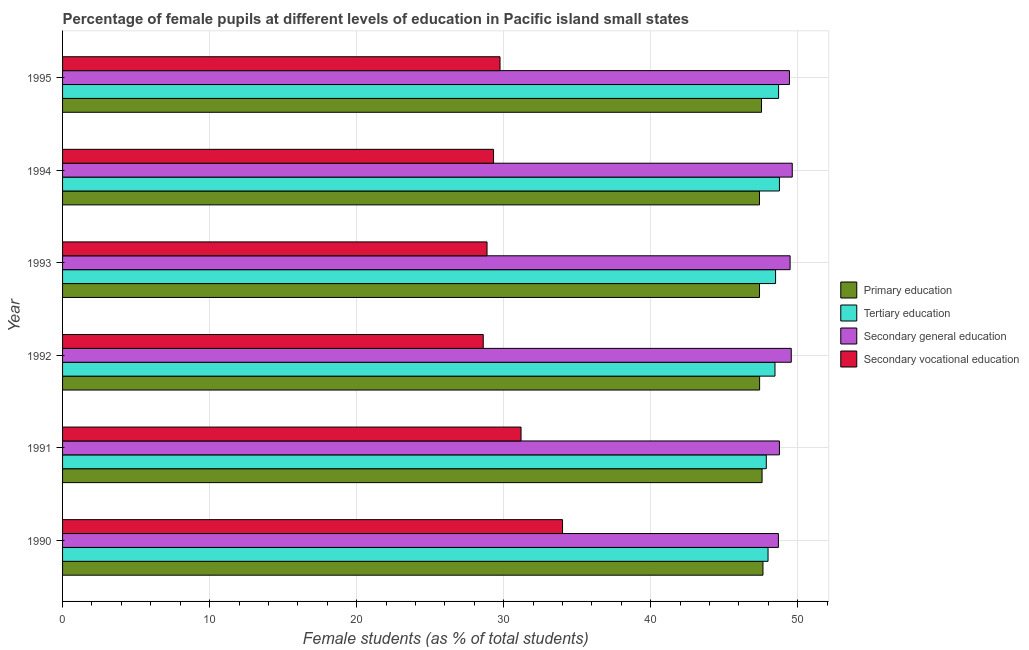How many different coloured bars are there?
Provide a short and direct response. 4. How many groups of bars are there?
Your answer should be compact. 6. Are the number of bars on each tick of the Y-axis equal?
Provide a succinct answer. Yes. How many bars are there on the 1st tick from the bottom?
Give a very brief answer. 4. What is the label of the 5th group of bars from the top?
Give a very brief answer. 1991. What is the percentage of female students in tertiary education in 1995?
Keep it short and to the point. 48.7. Across all years, what is the maximum percentage of female students in tertiary education?
Provide a short and direct response. 48.75. Across all years, what is the minimum percentage of female students in primary education?
Provide a short and direct response. 47.4. What is the total percentage of female students in primary education in the graph?
Provide a short and direct response. 284.94. What is the difference between the percentage of female students in secondary vocational education in 1990 and that in 1993?
Keep it short and to the point. 5.13. What is the difference between the percentage of female students in primary education in 1994 and the percentage of female students in secondary vocational education in 1992?
Your answer should be very brief. 18.79. What is the average percentage of female students in tertiary education per year?
Offer a terse response. 48.37. In the year 1993, what is the difference between the percentage of female students in secondary education and percentage of female students in tertiary education?
Give a very brief answer. 0.99. What is the ratio of the percentage of female students in primary education in 1990 to that in 1992?
Offer a terse response. 1. Is the percentage of female students in primary education in 1991 less than that in 1994?
Provide a succinct answer. No. Is the difference between the percentage of female students in tertiary education in 1990 and 1993 greater than the difference between the percentage of female students in secondary education in 1990 and 1993?
Make the answer very short. Yes. What is the difference between the highest and the second highest percentage of female students in secondary vocational education?
Provide a short and direct response. 2.82. What is the difference between the highest and the lowest percentage of female students in tertiary education?
Provide a short and direct response. 0.89. Is the sum of the percentage of female students in primary education in 1993 and 1994 greater than the maximum percentage of female students in secondary vocational education across all years?
Offer a very short reply. Yes. What does the 3rd bar from the top in 1990 represents?
Your response must be concise. Tertiary education. What does the 4th bar from the bottom in 1992 represents?
Offer a terse response. Secondary vocational education. How many bars are there?
Ensure brevity in your answer.  24. What is the difference between two consecutive major ticks on the X-axis?
Offer a terse response. 10. Are the values on the major ticks of X-axis written in scientific E-notation?
Your answer should be very brief. No. How are the legend labels stacked?
Make the answer very short. Vertical. What is the title of the graph?
Ensure brevity in your answer.  Percentage of female pupils at different levels of education in Pacific island small states. What is the label or title of the X-axis?
Make the answer very short. Female students (as % of total students). What is the Female students (as % of total students) of Primary education in 1990?
Give a very brief answer. 47.63. What is the Female students (as % of total students) in Tertiary education in 1990?
Give a very brief answer. 47.98. What is the Female students (as % of total students) of Secondary general education in 1990?
Offer a very short reply. 48.68. What is the Female students (as % of total students) in Secondary vocational education in 1990?
Provide a succinct answer. 34. What is the Female students (as % of total students) in Primary education in 1991?
Offer a terse response. 47.57. What is the Female students (as % of total students) of Tertiary education in 1991?
Your response must be concise. 47.86. What is the Female students (as % of total students) of Secondary general education in 1991?
Give a very brief answer. 48.75. What is the Female students (as % of total students) in Secondary vocational education in 1991?
Your answer should be compact. 31.18. What is the Female students (as % of total students) in Primary education in 1992?
Make the answer very short. 47.4. What is the Female students (as % of total students) of Tertiary education in 1992?
Your answer should be compact. 48.45. What is the Female students (as % of total students) of Secondary general education in 1992?
Keep it short and to the point. 49.56. What is the Female students (as % of total students) of Secondary vocational education in 1992?
Ensure brevity in your answer.  28.61. What is the Female students (as % of total students) of Primary education in 1993?
Your answer should be compact. 47.4. What is the Female students (as % of total students) in Tertiary education in 1993?
Your response must be concise. 48.49. What is the Female students (as % of total students) of Secondary general education in 1993?
Keep it short and to the point. 49.48. What is the Female students (as % of total students) in Secondary vocational education in 1993?
Ensure brevity in your answer.  28.87. What is the Female students (as % of total students) of Primary education in 1994?
Provide a succinct answer. 47.4. What is the Female students (as % of total students) of Tertiary education in 1994?
Your answer should be compact. 48.75. What is the Female students (as % of total students) in Secondary general education in 1994?
Keep it short and to the point. 49.63. What is the Female students (as % of total students) in Secondary vocational education in 1994?
Provide a short and direct response. 29.31. What is the Female students (as % of total students) of Primary education in 1995?
Ensure brevity in your answer.  47.53. What is the Female students (as % of total students) of Tertiary education in 1995?
Ensure brevity in your answer.  48.7. What is the Female students (as % of total students) of Secondary general education in 1995?
Provide a succinct answer. 49.43. What is the Female students (as % of total students) in Secondary vocational education in 1995?
Make the answer very short. 29.75. Across all years, what is the maximum Female students (as % of total students) of Primary education?
Your answer should be very brief. 47.63. Across all years, what is the maximum Female students (as % of total students) in Tertiary education?
Give a very brief answer. 48.75. Across all years, what is the maximum Female students (as % of total students) in Secondary general education?
Your answer should be very brief. 49.63. Across all years, what is the maximum Female students (as % of total students) in Secondary vocational education?
Your response must be concise. 34. Across all years, what is the minimum Female students (as % of total students) of Primary education?
Offer a very short reply. 47.4. Across all years, what is the minimum Female students (as % of total students) of Tertiary education?
Ensure brevity in your answer.  47.86. Across all years, what is the minimum Female students (as % of total students) in Secondary general education?
Your answer should be very brief. 48.68. Across all years, what is the minimum Female students (as % of total students) of Secondary vocational education?
Offer a very short reply. 28.61. What is the total Female students (as % of total students) of Primary education in the graph?
Your response must be concise. 284.94. What is the total Female students (as % of total students) in Tertiary education in the graph?
Your answer should be very brief. 290.22. What is the total Female students (as % of total students) in Secondary general education in the graph?
Provide a short and direct response. 295.53. What is the total Female students (as % of total students) in Secondary vocational education in the graph?
Give a very brief answer. 181.72. What is the difference between the Female students (as % of total students) in Primary education in 1990 and that in 1991?
Provide a succinct answer. 0.06. What is the difference between the Female students (as % of total students) of Tertiary education in 1990 and that in 1991?
Offer a very short reply. 0.12. What is the difference between the Female students (as % of total students) of Secondary general education in 1990 and that in 1991?
Keep it short and to the point. -0.07. What is the difference between the Female students (as % of total students) in Secondary vocational education in 1990 and that in 1991?
Your answer should be compact. 2.82. What is the difference between the Female students (as % of total students) in Primary education in 1990 and that in 1992?
Your answer should be very brief. 0.23. What is the difference between the Female students (as % of total students) of Tertiary education in 1990 and that in 1992?
Provide a succinct answer. -0.47. What is the difference between the Female students (as % of total students) in Secondary general education in 1990 and that in 1992?
Give a very brief answer. -0.87. What is the difference between the Female students (as % of total students) of Secondary vocational education in 1990 and that in 1992?
Give a very brief answer. 5.39. What is the difference between the Female students (as % of total students) of Primary education in 1990 and that in 1993?
Your answer should be compact. 0.23. What is the difference between the Female students (as % of total students) in Tertiary education in 1990 and that in 1993?
Ensure brevity in your answer.  -0.51. What is the difference between the Female students (as % of total students) of Secondary general education in 1990 and that in 1993?
Offer a terse response. -0.8. What is the difference between the Female students (as % of total students) of Secondary vocational education in 1990 and that in 1993?
Your response must be concise. 5.13. What is the difference between the Female students (as % of total students) in Primary education in 1990 and that in 1994?
Provide a short and direct response. 0.24. What is the difference between the Female students (as % of total students) of Tertiary education in 1990 and that in 1994?
Ensure brevity in your answer.  -0.77. What is the difference between the Female students (as % of total students) of Secondary general education in 1990 and that in 1994?
Provide a succinct answer. -0.94. What is the difference between the Female students (as % of total students) in Secondary vocational education in 1990 and that in 1994?
Keep it short and to the point. 4.69. What is the difference between the Female students (as % of total students) of Primary education in 1990 and that in 1995?
Give a very brief answer. 0.1. What is the difference between the Female students (as % of total students) in Tertiary education in 1990 and that in 1995?
Provide a succinct answer. -0.72. What is the difference between the Female students (as % of total students) in Secondary general education in 1990 and that in 1995?
Offer a very short reply. -0.75. What is the difference between the Female students (as % of total students) in Secondary vocational education in 1990 and that in 1995?
Give a very brief answer. 4.25. What is the difference between the Female students (as % of total students) in Primary education in 1991 and that in 1992?
Provide a short and direct response. 0.17. What is the difference between the Female students (as % of total students) in Tertiary education in 1991 and that in 1992?
Your response must be concise. -0.59. What is the difference between the Female students (as % of total students) in Secondary general education in 1991 and that in 1992?
Offer a very short reply. -0.8. What is the difference between the Female students (as % of total students) of Secondary vocational education in 1991 and that in 1992?
Make the answer very short. 2.57. What is the difference between the Female students (as % of total students) of Primary education in 1991 and that in 1993?
Offer a very short reply. 0.17. What is the difference between the Female students (as % of total students) of Tertiary education in 1991 and that in 1993?
Offer a terse response. -0.63. What is the difference between the Female students (as % of total students) of Secondary general education in 1991 and that in 1993?
Make the answer very short. -0.73. What is the difference between the Female students (as % of total students) of Secondary vocational education in 1991 and that in 1993?
Your answer should be very brief. 2.31. What is the difference between the Female students (as % of total students) of Primary education in 1991 and that in 1994?
Your answer should be compact. 0.18. What is the difference between the Female students (as % of total students) of Tertiary education in 1991 and that in 1994?
Keep it short and to the point. -0.89. What is the difference between the Female students (as % of total students) of Secondary general education in 1991 and that in 1994?
Make the answer very short. -0.87. What is the difference between the Female students (as % of total students) in Secondary vocational education in 1991 and that in 1994?
Offer a terse response. 1.87. What is the difference between the Female students (as % of total students) in Primary education in 1991 and that in 1995?
Provide a short and direct response. 0.04. What is the difference between the Female students (as % of total students) in Tertiary education in 1991 and that in 1995?
Offer a very short reply. -0.84. What is the difference between the Female students (as % of total students) of Secondary general education in 1991 and that in 1995?
Your answer should be very brief. -0.68. What is the difference between the Female students (as % of total students) in Secondary vocational education in 1991 and that in 1995?
Keep it short and to the point. 1.43. What is the difference between the Female students (as % of total students) in Primary education in 1992 and that in 1993?
Ensure brevity in your answer.  0.01. What is the difference between the Female students (as % of total students) of Tertiary education in 1992 and that in 1993?
Offer a very short reply. -0.04. What is the difference between the Female students (as % of total students) in Secondary general education in 1992 and that in 1993?
Your answer should be compact. 0.08. What is the difference between the Female students (as % of total students) of Secondary vocational education in 1992 and that in 1993?
Offer a very short reply. -0.26. What is the difference between the Female students (as % of total students) in Primary education in 1992 and that in 1994?
Make the answer very short. 0.01. What is the difference between the Female students (as % of total students) in Tertiary education in 1992 and that in 1994?
Offer a very short reply. -0.3. What is the difference between the Female students (as % of total students) of Secondary general education in 1992 and that in 1994?
Your answer should be compact. -0.07. What is the difference between the Female students (as % of total students) of Secondary vocational education in 1992 and that in 1994?
Ensure brevity in your answer.  -0.7. What is the difference between the Female students (as % of total students) in Primary education in 1992 and that in 1995?
Ensure brevity in your answer.  -0.13. What is the difference between the Female students (as % of total students) in Tertiary education in 1992 and that in 1995?
Your answer should be very brief. -0.25. What is the difference between the Female students (as % of total students) of Secondary general education in 1992 and that in 1995?
Offer a very short reply. 0.12. What is the difference between the Female students (as % of total students) in Secondary vocational education in 1992 and that in 1995?
Provide a succinct answer. -1.14. What is the difference between the Female students (as % of total students) in Primary education in 1993 and that in 1994?
Make the answer very short. 0. What is the difference between the Female students (as % of total students) of Tertiary education in 1993 and that in 1994?
Keep it short and to the point. -0.26. What is the difference between the Female students (as % of total students) of Secondary general education in 1993 and that in 1994?
Make the answer very short. -0.15. What is the difference between the Female students (as % of total students) in Secondary vocational education in 1993 and that in 1994?
Provide a short and direct response. -0.44. What is the difference between the Female students (as % of total students) in Primary education in 1993 and that in 1995?
Offer a terse response. -0.14. What is the difference between the Female students (as % of total students) of Tertiary education in 1993 and that in 1995?
Make the answer very short. -0.21. What is the difference between the Female students (as % of total students) in Secondary general education in 1993 and that in 1995?
Give a very brief answer. 0.04. What is the difference between the Female students (as % of total students) in Secondary vocational education in 1993 and that in 1995?
Offer a very short reply. -0.88. What is the difference between the Female students (as % of total students) of Primary education in 1994 and that in 1995?
Your answer should be compact. -0.14. What is the difference between the Female students (as % of total students) of Tertiary education in 1994 and that in 1995?
Provide a short and direct response. 0.06. What is the difference between the Female students (as % of total students) in Secondary general education in 1994 and that in 1995?
Provide a succinct answer. 0.19. What is the difference between the Female students (as % of total students) in Secondary vocational education in 1994 and that in 1995?
Offer a very short reply. -0.44. What is the difference between the Female students (as % of total students) of Primary education in 1990 and the Female students (as % of total students) of Tertiary education in 1991?
Your response must be concise. -0.23. What is the difference between the Female students (as % of total students) in Primary education in 1990 and the Female students (as % of total students) in Secondary general education in 1991?
Offer a very short reply. -1.12. What is the difference between the Female students (as % of total students) of Primary education in 1990 and the Female students (as % of total students) of Secondary vocational education in 1991?
Offer a terse response. 16.45. What is the difference between the Female students (as % of total students) in Tertiary education in 1990 and the Female students (as % of total students) in Secondary general education in 1991?
Ensure brevity in your answer.  -0.77. What is the difference between the Female students (as % of total students) in Tertiary education in 1990 and the Female students (as % of total students) in Secondary vocational education in 1991?
Your answer should be compact. 16.8. What is the difference between the Female students (as % of total students) in Secondary general education in 1990 and the Female students (as % of total students) in Secondary vocational education in 1991?
Your answer should be very brief. 17.5. What is the difference between the Female students (as % of total students) in Primary education in 1990 and the Female students (as % of total students) in Tertiary education in 1992?
Make the answer very short. -0.82. What is the difference between the Female students (as % of total students) in Primary education in 1990 and the Female students (as % of total students) in Secondary general education in 1992?
Offer a very short reply. -1.92. What is the difference between the Female students (as % of total students) in Primary education in 1990 and the Female students (as % of total students) in Secondary vocational education in 1992?
Offer a very short reply. 19.02. What is the difference between the Female students (as % of total students) of Tertiary education in 1990 and the Female students (as % of total students) of Secondary general education in 1992?
Provide a succinct answer. -1.58. What is the difference between the Female students (as % of total students) in Tertiary education in 1990 and the Female students (as % of total students) in Secondary vocational education in 1992?
Offer a terse response. 19.37. What is the difference between the Female students (as % of total students) of Secondary general education in 1990 and the Female students (as % of total students) of Secondary vocational education in 1992?
Make the answer very short. 20.07. What is the difference between the Female students (as % of total students) of Primary education in 1990 and the Female students (as % of total students) of Tertiary education in 1993?
Give a very brief answer. -0.86. What is the difference between the Female students (as % of total students) of Primary education in 1990 and the Female students (as % of total students) of Secondary general education in 1993?
Offer a terse response. -1.85. What is the difference between the Female students (as % of total students) of Primary education in 1990 and the Female students (as % of total students) of Secondary vocational education in 1993?
Offer a very short reply. 18.77. What is the difference between the Female students (as % of total students) of Tertiary education in 1990 and the Female students (as % of total students) of Secondary general education in 1993?
Keep it short and to the point. -1.5. What is the difference between the Female students (as % of total students) of Tertiary education in 1990 and the Female students (as % of total students) of Secondary vocational education in 1993?
Provide a short and direct response. 19.11. What is the difference between the Female students (as % of total students) of Secondary general education in 1990 and the Female students (as % of total students) of Secondary vocational education in 1993?
Offer a very short reply. 19.82. What is the difference between the Female students (as % of total students) in Primary education in 1990 and the Female students (as % of total students) in Tertiary education in 1994?
Ensure brevity in your answer.  -1.12. What is the difference between the Female students (as % of total students) of Primary education in 1990 and the Female students (as % of total students) of Secondary general education in 1994?
Make the answer very short. -1.99. What is the difference between the Female students (as % of total students) of Primary education in 1990 and the Female students (as % of total students) of Secondary vocational education in 1994?
Your response must be concise. 18.32. What is the difference between the Female students (as % of total students) in Tertiary education in 1990 and the Female students (as % of total students) in Secondary general education in 1994?
Keep it short and to the point. -1.65. What is the difference between the Female students (as % of total students) in Tertiary education in 1990 and the Female students (as % of total students) in Secondary vocational education in 1994?
Offer a very short reply. 18.67. What is the difference between the Female students (as % of total students) of Secondary general education in 1990 and the Female students (as % of total students) of Secondary vocational education in 1994?
Provide a succinct answer. 19.37. What is the difference between the Female students (as % of total students) of Primary education in 1990 and the Female students (as % of total students) of Tertiary education in 1995?
Ensure brevity in your answer.  -1.06. What is the difference between the Female students (as % of total students) in Primary education in 1990 and the Female students (as % of total students) in Secondary general education in 1995?
Your answer should be very brief. -1.8. What is the difference between the Female students (as % of total students) in Primary education in 1990 and the Female students (as % of total students) in Secondary vocational education in 1995?
Your response must be concise. 17.88. What is the difference between the Female students (as % of total students) of Tertiary education in 1990 and the Female students (as % of total students) of Secondary general education in 1995?
Offer a terse response. -1.46. What is the difference between the Female students (as % of total students) of Tertiary education in 1990 and the Female students (as % of total students) of Secondary vocational education in 1995?
Your answer should be very brief. 18.23. What is the difference between the Female students (as % of total students) of Secondary general education in 1990 and the Female students (as % of total students) of Secondary vocational education in 1995?
Make the answer very short. 18.93. What is the difference between the Female students (as % of total students) of Primary education in 1991 and the Female students (as % of total students) of Tertiary education in 1992?
Provide a succinct answer. -0.88. What is the difference between the Female students (as % of total students) of Primary education in 1991 and the Female students (as % of total students) of Secondary general education in 1992?
Provide a short and direct response. -1.98. What is the difference between the Female students (as % of total students) of Primary education in 1991 and the Female students (as % of total students) of Secondary vocational education in 1992?
Your answer should be very brief. 18.96. What is the difference between the Female students (as % of total students) in Tertiary education in 1991 and the Female students (as % of total students) in Secondary general education in 1992?
Provide a short and direct response. -1.7. What is the difference between the Female students (as % of total students) in Tertiary education in 1991 and the Female students (as % of total students) in Secondary vocational education in 1992?
Ensure brevity in your answer.  19.25. What is the difference between the Female students (as % of total students) in Secondary general education in 1991 and the Female students (as % of total students) in Secondary vocational education in 1992?
Offer a very short reply. 20.14. What is the difference between the Female students (as % of total students) of Primary education in 1991 and the Female students (as % of total students) of Tertiary education in 1993?
Your answer should be very brief. -0.92. What is the difference between the Female students (as % of total students) of Primary education in 1991 and the Female students (as % of total students) of Secondary general education in 1993?
Your answer should be very brief. -1.91. What is the difference between the Female students (as % of total students) of Primary education in 1991 and the Female students (as % of total students) of Secondary vocational education in 1993?
Offer a terse response. 18.71. What is the difference between the Female students (as % of total students) of Tertiary education in 1991 and the Female students (as % of total students) of Secondary general education in 1993?
Keep it short and to the point. -1.62. What is the difference between the Female students (as % of total students) of Tertiary education in 1991 and the Female students (as % of total students) of Secondary vocational education in 1993?
Provide a succinct answer. 18.99. What is the difference between the Female students (as % of total students) in Secondary general education in 1991 and the Female students (as % of total students) in Secondary vocational education in 1993?
Provide a short and direct response. 19.89. What is the difference between the Female students (as % of total students) in Primary education in 1991 and the Female students (as % of total students) in Tertiary education in 1994?
Provide a succinct answer. -1.18. What is the difference between the Female students (as % of total students) of Primary education in 1991 and the Female students (as % of total students) of Secondary general education in 1994?
Your response must be concise. -2.05. What is the difference between the Female students (as % of total students) of Primary education in 1991 and the Female students (as % of total students) of Secondary vocational education in 1994?
Ensure brevity in your answer.  18.26. What is the difference between the Female students (as % of total students) in Tertiary education in 1991 and the Female students (as % of total students) in Secondary general education in 1994?
Your answer should be very brief. -1.77. What is the difference between the Female students (as % of total students) of Tertiary education in 1991 and the Female students (as % of total students) of Secondary vocational education in 1994?
Make the answer very short. 18.55. What is the difference between the Female students (as % of total students) of Secondary general education in 1991 and the Female students (as % of total students) of Secondary vocational education in 1994?
Your answer should be compact. 19.44. What is the difference between the Female students (as % of total students) of Primary education in 1991 and the Female students (as % of total students) of Tertiary education in 1995?
Your answer should be compact. -1.12. What is the difference between the Female students (as % of total students) in Primary education in 1991 and the Female students (as % of total students) in Secondary general education in 1995?
Ensure brevity in your answer.  -1.86. What is the difference between the Female students (as % of total students) of Primary education in 1991 and the Female students (as % of total students) of Secondary vocational education in 1995?
Your answer should be compact. 17.82. What is the difference between the Female students (as % of total students) of Tertiary education in 1991 and the Female students (as % of total students) of Secondary general education in 1995?
Your answer should be compact. -1.57. What is the difference between the Female students (as % of total students) in Tertiary education in 1991 and the Female students (as % of total students) in Secondary vocational education in 1995?
Your answer should be compact. 18.11. What is the difference between the Female students (as % of total students) in Secondary general education in 1991 and the Female students (as % of total students) in Secondary vocational education in 1995?
Your response must be concise. 19. What is the difference between the Female students (as % of total students) of Primary education in 1992 and the Female students (as % of total students) of Tertiary education in 1993?
Your response must be concise. -1.09. What is the difference between the Female students (as % of total students) in Primary education in 1992 and the Female students (as % of total students) in Secondary general education in 1993?
Keep it short and to the point. -2.07. What is the difference between the Female students (as % of total students) in Primary education in 1992 and the Female students (as % of total students) in Secondary vocational education in 1993?
Ensure brevity in your answer.  18.54. What is the difference between the Female students (as % of total students) of Tertiary education in 1992 and the Female students (as % of total students) of Secondary general education in 1993?
Keep it short and to the point. -1.03. What is the difference between the Female students (as % of total students) in Tertiary education in 1992 and the Female students (as % of total students) in Secondary vocational education in 1993?
Keep it short and to the point. 19.58. What is the difference between the Female students (as % of total students) in Secondary general education in 1992 and the Female students (as % of total students) in Secondary vocational education in 1993?
Make the answer very short. 20.69. What is the difference between the Female students (as % of total students) in Primary education in 1992 and the Female students (as % of total students) in Tertiary education in 1994?
Keep it short and to the point. -1.35. What is the difference between the Female students (as % of total students) of Primary education in 1992 and the Female students (as % of total students) of Secondary general education in 1994?
Provide a short and direct response. -2.22. What is the difference between the Female students (as % of total students) of Primary education in 1992 and the Female students (as % of total students) of Secondary vocational education in 1994?
Give a very brief answer. 18.09. What is the difference between the Female students (as % of total students) of Tertiary education in 1992 and the Female students (as % of total students) of Secondary general education in 1994?
Provide a succinct answer. -1.18. What is the difference between the Female students (as % of total students) in Tertiary education in 1992 and the Female students (as % of total students) in Secondary vocational education in 1994?
Provide a short and direct response. 19.14. What is the difference between the Female students (as % of total students) in Secondary general education in 1992 and the Female students (as % of total students) in Secondary vocational education in 1994?
Your response must be concise. 20.25. What is the difference between the Female students (as % of total students) in Primary education in 1992 and the Female students (as % of total students) in Tertiary education in 1995?
Your answer should be very brief. -1.29. What is the difference between the Female students (as % of total students) of Primary education in 1992 and the Female students (as % of total students) of Secondary general education in 1995?
Ensure brevity in your answer.  -2.03. What is the difference between the Female students (as % of total students) of Primary education in 1992 and the Female students (as % of total students) of Secondary vocational education in 1995?
Your answer should be very brief. 17.65. What is the difference between the Female students (as % of total students) of Tertiary education in 1992 and the Female students (as % of total students) of Secondary general education in 1995?
Give a very brief answer. -0.98. What is the difference between the Female students (as % of total students) of Tertiary education in 1992 and the Female students (as % of total students) of Secondary vocational education in 1995?
Keep it short and to the point. 18.7. What is the difference between the Female students (as % of total students) of Secondary general education in 1992 and the Female students (as % of total students) of Secondary vocational education in 1995?
Provide a short and direct response. 19.81. What is the difference between the Female students (as % of total students) in Primary education in 1993 and the Female students (as % of total students) in Tertiary education in 1994?
Keep it short and to the point. -1.35. What is the difference between the Female students (as % of total students) in Primary education in 1993 and the Female students (as % of total students) in Secondary general education in 1994?
Make the answer very short. -2.23. What is the difference between the Female students (as % of total students) in Primary education in 1993 and the Female students (as % of total students) in Secondary vocational education in 1994?
Offer a terse response. 18.09. What is the difference between the Female students (as % of total students) in Tertiary education in 1993 and the Female students (as % of total students) in Secondary general education in 1994?
Make the answer very short. -1.14. What is the difference between the Female students (as % of total students) of Tertiary education in 1993 and the Female students (as % of total students) of Secondary vocational education in 1994?
Provide a succinct answer. 19.18. What is the difference between the Female students (as % of total students) of Secondary general education in 1993 and the Female students (as % of total students) of Secondary vocational education in 1994?
Your response must be concise. 20.17. What is the difference between the Female students (as % of total students) in Primary education in 1993 and the Female students (as % of total students) in Tertiary education in 1995?
Offer a very short reply. -1.3. What is the difference between the Female students (as % of total students) in Primary education in 1993 and the Female students (as % of total students) in Secondary general education in 1995?
Make the answer very short. -2.04. What is the difference between the Female students (as % of total students) of Primary education in 1993 and the Female students (as % of total students) of Secondary vocational education in 1995?
Your answer should be compact. 17.65. What is the difference between the Female students (as % of total students) of Tertiary education in 1993 and the Female students (as % of total students) of Secondary general education in 1995?
Keep it short and to the point. -0.94. What is the difference between the Female students (as % of total students) of Tertiary education in 1993 and the Female students (as % of total students) of Secondary vocational education in 1995?
Ensure brevity in your answer.  18.74. What is the difference between the Female students (as % of total students) in Secondary general education in 1993 and the Female students (as % of total students) in Secondary vocational education in 1995?
Make the answer very short. 19.73. What is the difference between the Female students (as % of total students) in Primary education in 1994 and the Female students (as % of total students) in Tertiary education in 1995?
Offer a terse response. -1.3. What is the difference between the Female students (as % of total students) in Primary education in 1994 and the Female students (as % of total students) in Secondary general education in 1995?
Provide a succinct answer. -2.04. What is the difference between the Female students (as % of total students) of Primary education in 1994 and the Female students (as % of total students) of Secondary vocational education in 1995?
Your answer should be very brief. 17.65. What is the difference between the Female students (as % of total students) of Tertiary education in 1994 and the Female students (as % of total students) of Secondary general education in 1995?
Your answer should be compact. -0.68. What is the difference between the Female students (as % of total students) of Tertiary education in 1994 and the Female students (as % of total students) of Secondary vocational education in 1995?
Provide a short and direct response. 19. What is the difference between the Female students (as % of total students) in Secondary general education in 1994 and the Female students (as % of total students) in Secondary vocational education in 1995?
Your response must be concise. 19.88. What is the average Female students (as % of total students) of Primary education per year?
Make the answer very short. 47.49. What is the average Female students (as % of total students) in Tertiary education per year?
Your answer should be very brief. 48.37. What is the average Female students (as % of total students) in Secondary general education per year?
Provide a succinct answer. 49.25. What is the average Female students (as % of total students) of Secondary vocational education per year?
Offer a very short reply. 30.29. In the year 1990, what is the difference between the Female students (as % of total students) of Primary education and Female students (as % of total students) of Tertiary education?
Offer a very short reply. -0.35. In the year 1990, what is the difference between the Female students (as % of total students) in Primary education and Female students (as % of total students) in Secondary general education?
Ensure brevity in your answer.  -1.05. In the year 1990, what is the difference between the Female students (as % of total students) in Primary education and Female students (as % of total students) in Secondary vocational education?
Provide a short and direct response. 13.63. In the year 1990, what is the difference between the Female students (as % of total students) in Tertiary education and Female students (as % of total students) in Secondary general education?
Offer a very short reply. -0.7. In the year 1990, what is the difference between the Female students (as % of total students) of Tertiary education and Female students (as % of total students) of Secondary vocational education?
Give a very brief answer. 13.98. In the year 1990, what is the difference between the Female students (as % of total students) of Secondary general education and Female students (as % of total students) of Secondary vocational education?
Offer a terse response. 14.68. In the year 1991, what is the difference between the Female students (as % of total students) in Primary education and Female students (as % of total students) in Tertiary education?
Offer a very short reply. -0.29. In the year 1991, what is the difference between the Female students (as % of total students) in Primary education and Female students (as % of total students) in Secondary general education?
Offer a terse response. -1.18. In the year 1991, what is the difference between the Female students (as % of total students) of Primary education and Female students (as % of total students) of Secondary vocational education?
Your answer should be compact. 16.39. In the year 1991, what is the difference between the Female students (as % of total students) in Tertiary education and Female students (as % of total students) in Secondary general education?
Offer a very short reply. -0.89. In the year 1991, what is the difference between the Female students (as % of total students) in Tertiary education and Female students (as % of total students) in Secondary vocational education?
Make the answer very short. 16.68. In the year 1991, what is the difference between the Female students (as % of total students) of Secondary general education and Female students (as % of total students) of Secondary vocational education?
Provide a short and direct response. 17.57. In the year 1992, what is the difference between the Female students (as % of total students) of Primary education and Female students (as % of total students) of Tertiary education?
Your answer should be compact. -1.05. In the year 1992, what is the difference between the Female students (as % of total students) of Primary education and Female students (as % of total students) of Secondary general education?
Keep it short and to the point. -2.15. In the year 1992, what is the difference between the Female students (as % of total students) of Primary education and Female students (as % of total students) of Secondary vocational education?
Your response must be concise. 18.8. In the year 1992, what is the difference between the Female students (as % of total students) in Tertiary education and Female students (as % of total students) in Secondary general education?
Your answer should be very brief. -1.11. In the year 1992, what is the difference between the Female students (as % of total students) of Tertiary education and Female students (as % of total students) of Secondary vocational education?
Offer a very short reply. 19.84. In the year 1992, what is the difference between the Female students (as % of total students) in Secondary general education and Female students (as % of total students) in Secondary vocational education?
Your response must be concise. 20.95. In the year 1993, what is the difference between the Female students (as % of total students) in Primary education and Female students (as % of total students) in Tertiary education?
Provide a succinct answer. -1.09. In the year 1993, what is the difference between the Female students (as % of total students) of Primary education and Female students (as % of total students) of Secondary general education?
Make the answer very short. -2.08. In the year 1993, what is the difference between the Female students (as % of total students) in Primary education and Female students (as % of total students) in Secondary vocational education?
Your response must be concise. 18.53. In the year 1993, what is the difference between the Female students (as % of total students) in Tertiary education and Female students (as % of total students) in Secondary general education?
Give a very brief answer. -0.99. In the year 1993, what is the difference between the Female students (as % of total students) in Tertiary education and Female students (as % of total students) in Secondary vocational education?
Your response must be concise. 19.62. In the year 1993, what is the difference between the Female students (as % of total students) of Secondary general education and Female students (as % of total students) of Secondary vocational education?
Your answer should be compact. 20.61. In the year 1994, what is the difference between the Female students (as % of total students) in Primary education and Female students (as % of total students) in Tertiary education?
Offer a terse response. -1.36. In the year 1994, what is the difference between the Female students (as % of total students) in Primary education and Female students (as % of total students) in Secondary general education?
Keep it short and to the point. -2.23. In the year 1994, what is the difference between the Female students (as % of total students) in Primary education and Female students (as % of total students) in Secondary vocational education?
Your answer should be very brief. 18.09. In the year 1994, what is the difference between the Female students (as % of total students) of Tertiary education and Female students (as % of total students) of Secondary general education?
Keep it short and to the point. -0.87. In the year 1994, what is the difference between the Female students (as % of total students) in Tertiary education and Female students (as % of total students) in Secondary vocational education?
Keep it short and to the point. 19.44. In the year 1994, what is the difference between the Female students (as % of total students) in Secondary general education and Female students (as % of total students) in Secondary vocational education?
Provide a short and direct response. 20.32. In the year 1995, what is the difference between the Female students (as % of total students) of Primary education and Female students (as % of total students) of Tertiary education?
Ensure brevity in your answer.  -1.16. In the year 1995, what is the difference between the Female students (as % of total students) of Primary education and Female students (as % of total students) of Secondary general education?
Your answer should be compact. -1.9. In the year 1995, what is the difference between the Female students (as % of total students) in Primary education and Female students (as % of total students) in Secondary vocational education?
Your response must be concise. 17.78. In the year 1995, what is the difference between the Female students (as % of total students) in Tertiary education and Female students (as % of total students) in Secondary general education?
Provide a succinct answer. -0.74. In the year 1995, what is the difference between the Female students (as % of total students) of Tertiary education and Female students (as % of total students) of Secondary vocational education?
Provide a succinct answer. 18.95. In the year 1995, what is the difference between the Female students (as % of total students) of Secondary general education and Female students (as % of total students) of Secondary vocational education?
Your answer should be compact. 19.68. What is the ratio of the Female students (as % of total students) of Secondary general education in 1990 to that in 1991?
Your response must be concise. 1. What is the ratio of the Female students (as % of total students) in Secondary vocational education in 1990 to that in 1991?
Your answer should be very brief. 1.09. What is the ratio of the Female students (as % of total students) in Tertiary education in 1990 to that in 1992?
Provide a short and direct response. 0.99. What is the ratio of the Female students (as % of total students) of Secondary general education in 1990 to that in 1992?
Your response must be concise. 0.98. What is the ratio of the Female students (as % of total students) in Secondary vocational education in 1990 to that in 1992?
Your answer should be very brief. 1.19. What is the ratio of the Female students (as % of total students) of Primary education in 1990 to that in 1993?
Ensure brevity in your answer.  1. What is the ratio of the Female students (as % of total students) in Tertiary education in 1990 to that in 1993?
Give a very brief answer. 0.99. What is the ratio of the Female students (as % of total students) of Secondary general education in 1990 to that in 1993?
Offer a very short reply. 0.98. What is the ratio of the Female students (as % of total students) in Secondary vocational education in 1990 to that in 1993?
Make the answer very short. 1.18. What is the ratio of the Female students (as % of total students) of Primary education in 1990 to that in 1994?
Keep it short and to the point. 1. What is the ratio of the Female students (as % of total students) in Tertiary education in 1990 to that in 1994?
Ensure brevity in your answer.  0.98. What is the ratio of the Female students (as % of total students) of Secondary general education in 1990 to that in 1994?
Offer a very short reply. 0.98. What is the ratio of the Female students (as % of total students) in Secondary vocational education in 1990 to that in 1994?
Offer a very short reply. 1.16. What is the ratio of the Female students (as % of total students) of Secondary general education in 1990 to that in 1995?
Make the answer very short. 0.98. What is the ratio of the Female students (as % of total students) in Secondary vocational education in 1990 to that in 1995?
Ensure brevity in your answer.  1.14. What is the ratio of the Female students (as % of total students) of Primary education in 1991 to that in 1992?
Your answer should be very brief. 1. What is the ratio of the Female students (as % of total students) in Secondary general education in 1991 to that in 1992?
Provide a short and direct response. 0.98. What is the ratio of the Female students (as % of total students) in Secondary vocational education in 1991 to that in 1992?
Make the answer very short. 1.09. What is the ratio of the Female students (as % of total students) in Primary education in 1991 to that in 1993?
Your answer should be compact. 1. What is the ratio of the Female students (as % of total students) of Tertiary education in 1991 to that in 1993?
Make the answer very short. 0.99. What is the ratio of the Female students (as % of total students) in Secondary vocational education in 1991 to that in 1993?
Offer a terse response. 1.08. What is the ratio of the Female students (as % of total students) of Tertiary education in 1991 to that in 1994?
Provide a succinct answer. 0.98. What is the ratio of the Female students (as % of total students) in Secondary general education in 1991 to that in 1994?
Your answer should be very brief. 0.98. What is the ratio of the Female students (as % of total students) of Secondary vocational education in 1991 to that in 1994?
Make the answer very short. 1.06. What is the ratio of the Female students (as % of total students) in Tertiary education in 1991 to that in 1995?
Your answer should be very brief. 0.98. What is the ratio of the Female students (as % of total students) of Secondary general education in 1991 to that in 1995?
Provide a succinct answer. 0.99. What is the ratio of the Female students (as % of total students) of Secondary vocational education in 1991 to that in 1995?
Give a very brief answer. 1.05. What is the ratio of the Female students (as % of total students) of Primary education in 1992 to that in 1994?
Keep it short and to the point. 1. What is the ratio of the Female students (as % of total students) in Secondary general education in 1992 to that in 1994?
Your response must be concise. 1. What is the ratio of the Female students (as % of total students) of Secondary vocational education in 1992 to that in 1994?
Provide a succinct answer. 0.98. What is the ratio of the Female students (as % of total students) of Primary education in 1992 to that in 1995?
Give a very brief answer. 1. What is the ratio of the Female students (as % of total students) in Secondary general education in 1992 to that in 1995?
Your answer should be compact. 1. What is the ratio of the Female students (as % of total students) of Secondary vocational education in 1992 to that in 1995?
Ensure brevity in your answer.  0.96. What is the ratio of the Female students (as % of total students) of Secondary vocational education in 1993 to that in 1994?
Offer a very short reply. 0.98. What is the ratio of the Female students (as % of total students) in Secondary general education in 1993 to that in 1995?
Provide a succinct answer. 1. What is the ratio of the Female students (as % of total students) in Secondary vocational education in 1993 to that in 1995?
Your answer should be compact. 0.97. What is the ratio of the Female students (as % of total students) of Primary education in 1994 to that in 1995?
Offer a terse response. 1. What is the ratio of the Female students (as % of total students) in Secondary vocational education in 1994 to that in 1995?
Provide a short and direct response. 0.99. What is the difference between the highest and the second highest Female students (as % of total students) of Primary education?
Your answer should be compact. 0.06. What is the difference between the highest and the second highest Female students (as % of total students) of Tertiary education?
Provide a succinct answer. 0.06. What is the difference between the highest and the second highest Female students (as % of total students) in Secondary general education?
Your answer should be very brief. 0.07. What is the difference between the highest and the second highest Female students (as % of total students) in Secondary vocational education?
Offer a very short reply. 2.82. What is the difference between the highest and the lowest Female students (as % of total students) of Primary education?
Keep it short and to the point. 0.24. What is the difference between the highest and the lowest Female students (as % of total students) of Tertiary education?
Offer a terse response. 0.89. What is the difference between the highest and the lowest Female students (as % of total students) of Secondary general education?
Your response must be concise. 0.94. What is the difference between the highest and the lowest Female students (as % of total students) in Secondary vocational education?
Your answer should be very brief. 5.39. 